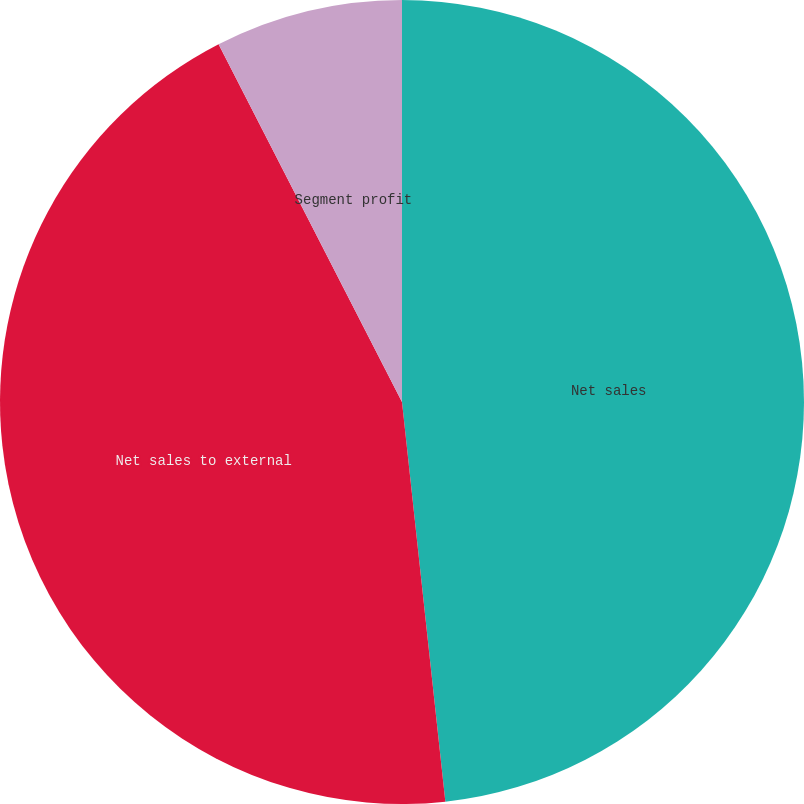Convert chart. <chart><loc_0><loc_0><loc_500><loc_500><pie_chart><fcel>Net sales<fcel>Net sales to external<fcel>Segment profit<nl><fcel>48.28%<fcel>44.18%<fcel>7.54%<nl></chart> 